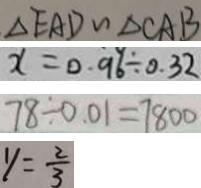<formula> <loc_0><loc_0><loc_500><loc_500>\Delta E A D \sim \Delta C A B 
 x = 0 . 9 6 \div 0 . 3 2 
 7 8 \div 0 . 0 1 = 7 8 0 0 
 y = \frac { 2 } { 3 }</formula> 